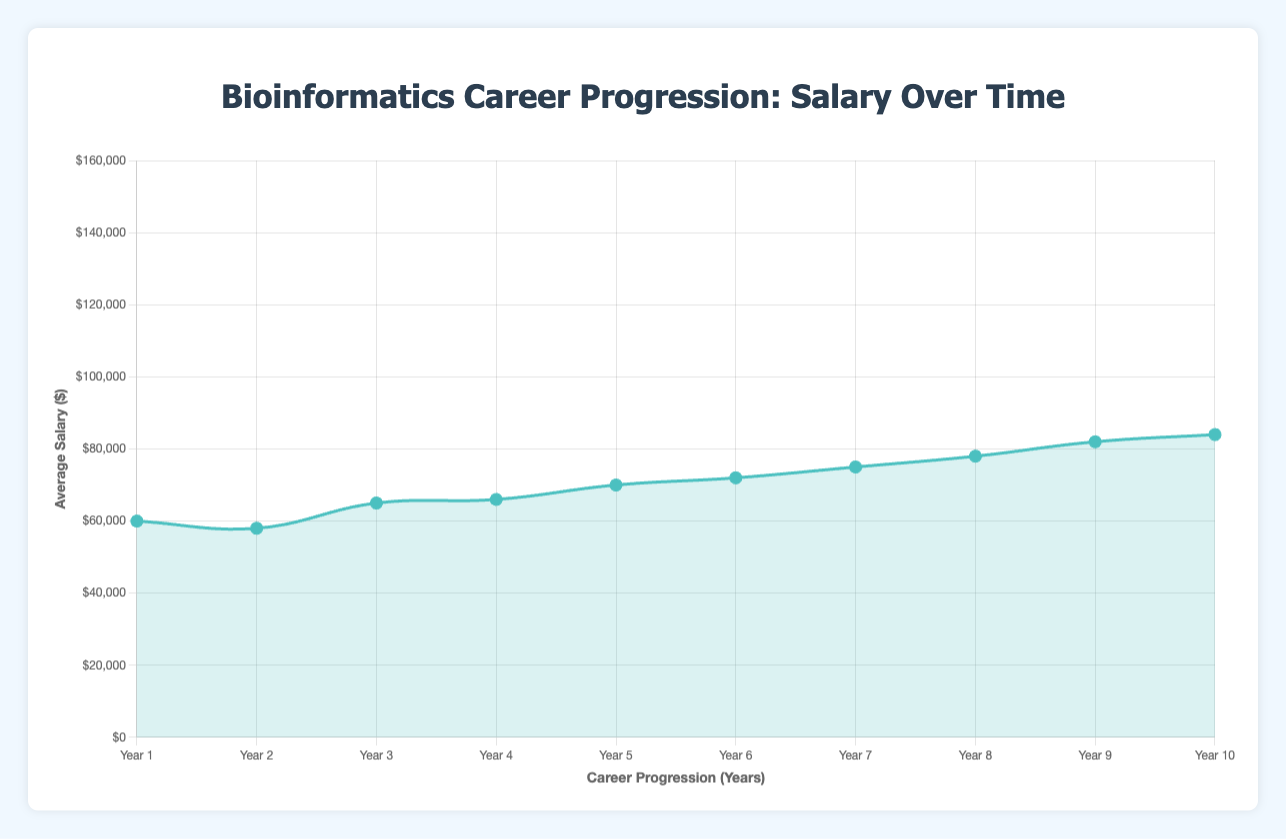What's the average salary in Year 4? We have two salaries in Year 4: $75,000 and $78,000. Calculate the average by summing them (75000 + 78000 = 153000) and dividing by 2. The average salary is 153000 / 2 = $76,500
Answer: $76,500 How much does the average salary increase from Year 5 to Year 6? The average salary in Year 5 is $82,000 at Gilead Sciences and $84,000 at Merck. First, find the average for Year 5: (82000 + 84000) / 2 = $83,000. For Year 6, the salaries are $90,000 at Amgen and $92,000 at Regeneron. Calculate the average for Year 6: (90000 + 92000) / 2 = $91,000. The increase is $91,000 - $83,000 = $8,000
Answer: $8,000 Which year has the highest average salary? By comparing the average salaries of each year, it's clear that Year 10 has the highest average salary with $150,000 at Sanofi and $160,000 at BioNTech. Hence, the average salary for Year 10 is (150000 + 160000) / 2 = $155,000, which is greater than the other years
Answer: Year 10 What is the salary difference between the Junior Bioinformatics Analyst at Genentech and the Chief Bioinformatics Scientist at BioNTech? The salary for the Junior Bioinformatics Analyst at Genentech is $60,000, while the salary for the Chief Bioinformatics Scientist at BioNTech is $160,000. The difference is $160,000 - $60,000 = $100,000
Answer: $100,000 How much did the average salary in Year 7 differ from that in Year 8? For Year 7, the salaries are $100,000 at AbbVie and $105,000 at Biogen. Calculate the average for Year 7: (100000 + 105000) / 2 = $102,500. For Year 8, the salaries are $115,000 at Vertex Pharmaceuticals and $120,000 at Moderna. Calculate the average for Year 8: (115000 + 120000) / 2 = $117,500. The difference is $117,500 - $102,500 = $15,000
Answer: $15,000 What is the average salary for the entire 10-year period? Calculate the sum of all average salaries listed in the dataset and divide by the number of data points (20). Sum of all average salaries is 1209000. The average for all years is 1209000 / 20 = $60,450
Answer: $60,450 Compare the salary progression from Year 1 to Year 10. The starting average salary in Year 1 at Genentech and Broad Institute is (60000 + 58000) / 2 = $59,000. The ending average salary in Year 10 at Sanofi and BioNTech is (150000 + 160000) / 2 = $155,000. The progression from Year 1 to 10 is governed by the formula (ending salary - starting salary) / starting salary * 100%. The growth is (155000 - 59000) / 59000 * 100% ≈ 162.71%
Answer: 162.71% What's the position with the highest salary and which company offers it? According to the dataset, BioNTech offers the highest salary ($160,000) for the position of Chief Bioinformatics Scientist in Year 10
Answer: Chief Bioinformatics Scientist at BioNTech Between which two consecutive years is the salary change smallest, and what is the amount? To find this, calculate the average salary of each year first and then identify the smallest difference between consecutive years' average salaries. Year pairs' differences: Year 3 to 4 (76500 - 71000), Year 4 to 5 (83000 - 76500) etc. The smallest difference is between Year 5 and Year 6, calculated earlier to be $8,000.
Answer: Year 5 to Year 6, $8,000 What is the median salary in Year 7? Salaries for Year 7 are $100,000 at AbbVie and $105,000 at Biogen. Since there are only two data points, they represent the high and low ends of our dataset, making $102,500 the median salary. The calculation involves (100000 + 105000) / 2 = $102,500
Answer: $102,500 